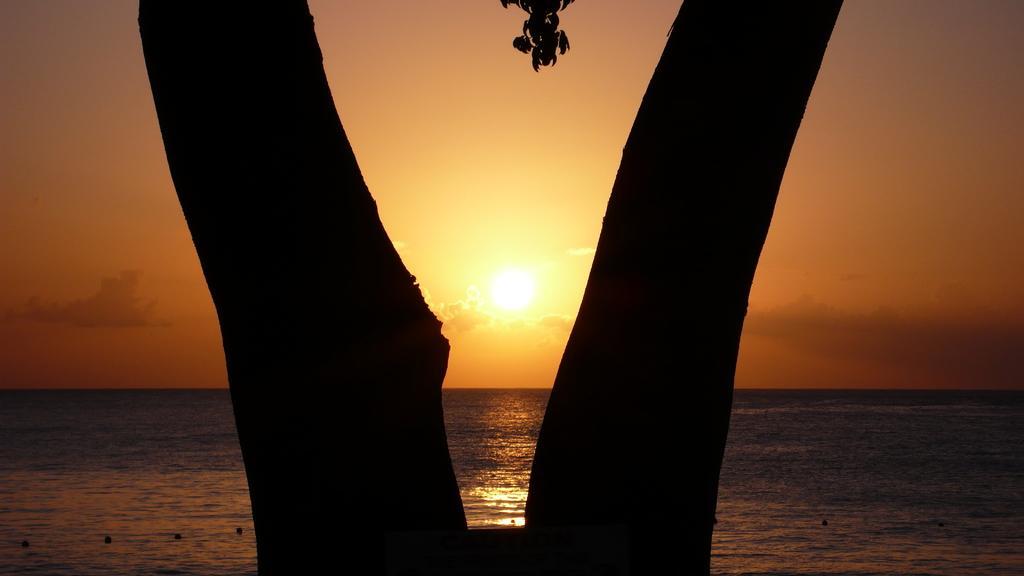Please provide a concise description of this image. In the middle of the image there is a tree. Behind the tree there is water and clouds and sky and sun. 